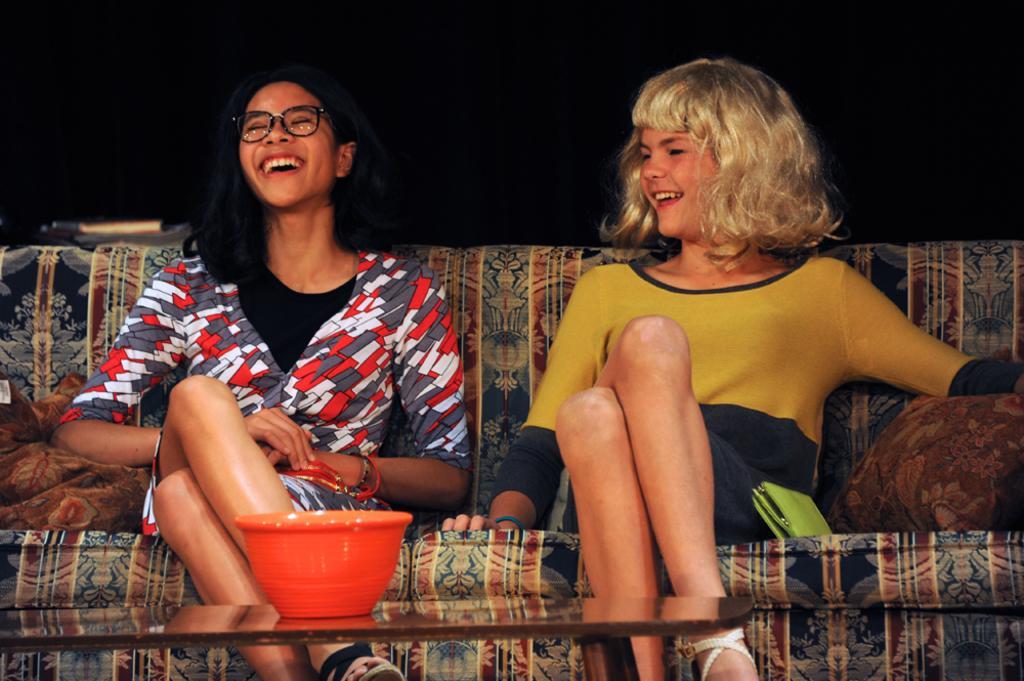Could you give a brief overview of what you see in this image? In this image I can see two persons are sitting on a sofa in front of a table on which a bowl is kept. In the background, I can see a dark color. This image is taken may be in a hall. 